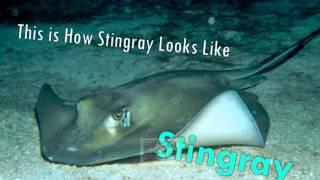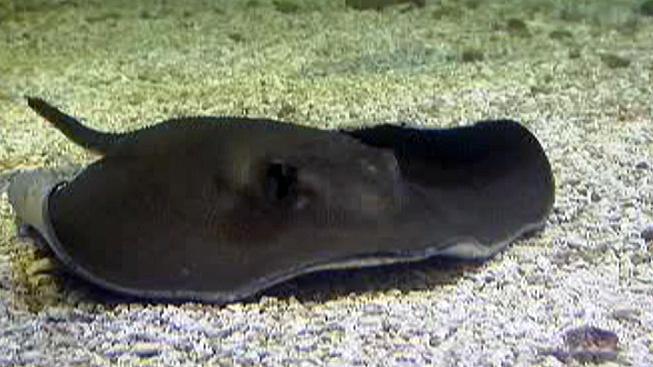The first image is the image on the left, the second image is the image on the right. For the images displayed, is the sentence "The stingrays in each pair are looking in the opposite direction from each other." factually correct? Answer yes or no. Yes. 